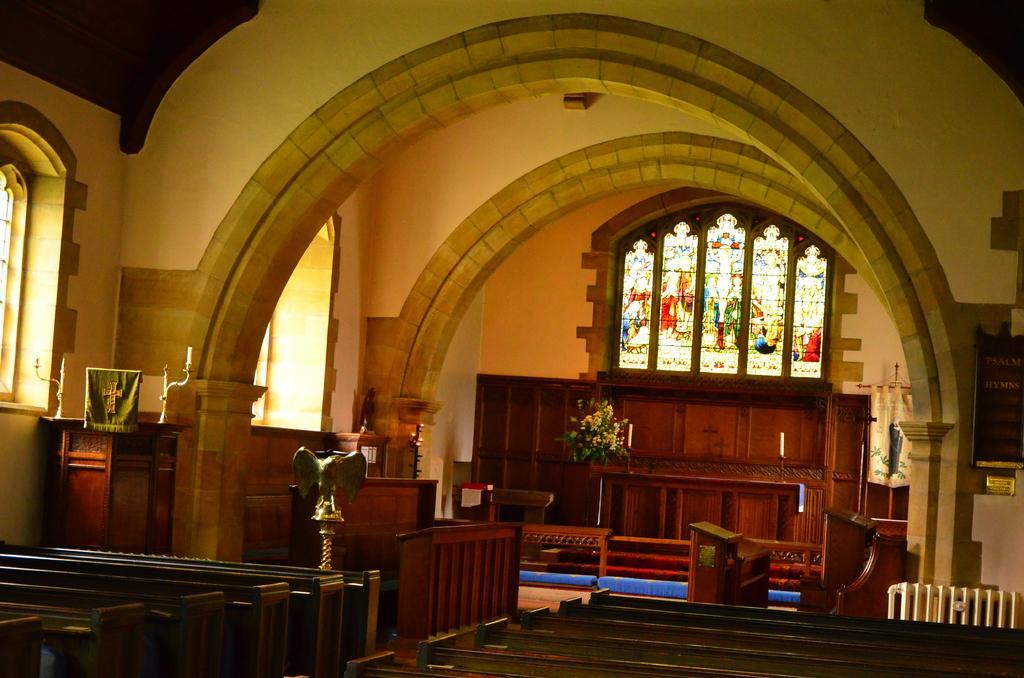Can you describe this image briefly? This is the inside view of a building. Here we can see benches, plant, table, frame, cupboards, and windows. In the background there is a wall. 